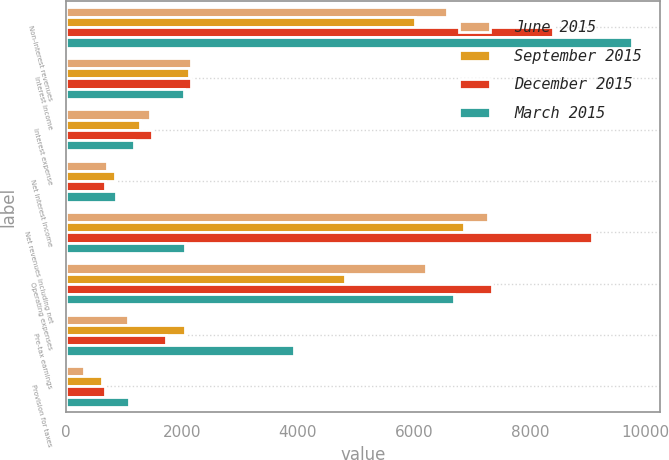<chart> <loc_0><loc_0><loc_500><loc_500><stacked_bar_chart><ecel><fcel>Non-interest revenues<fcel>Interest income<fcel>Interest expense<fcel>Net interest income<fcel>Net revenues including net<fcel>Operating expenses<fcel>Pre-tax earnings<fcel>Provision for taxes<nl><fcel>June 2015<fcel>6573<fcel>2148<fcel>1448<fcel>700<fcel>7273<fcel>6201<fcel>1072<fcel>307<nl><fcel>September 2015<fcel>6019<fcel>2119<fcel>1277<fcel>842<fcel>6861<fcel>4815<fcel>2046<fcel>620<nl><fcel>December 2015<fcel>8406<fcel>2150<fcel>1487<fcel>663<fcel>9069<fcel>7343<fcel>1726<fcel>678<nl><fcel>March 2015<fcel>9758<fcel>2035<fcel>1176<fcel>859<fcel>2046<fcel>6683<fcel>3934<fcel>1090<nl></chart> 